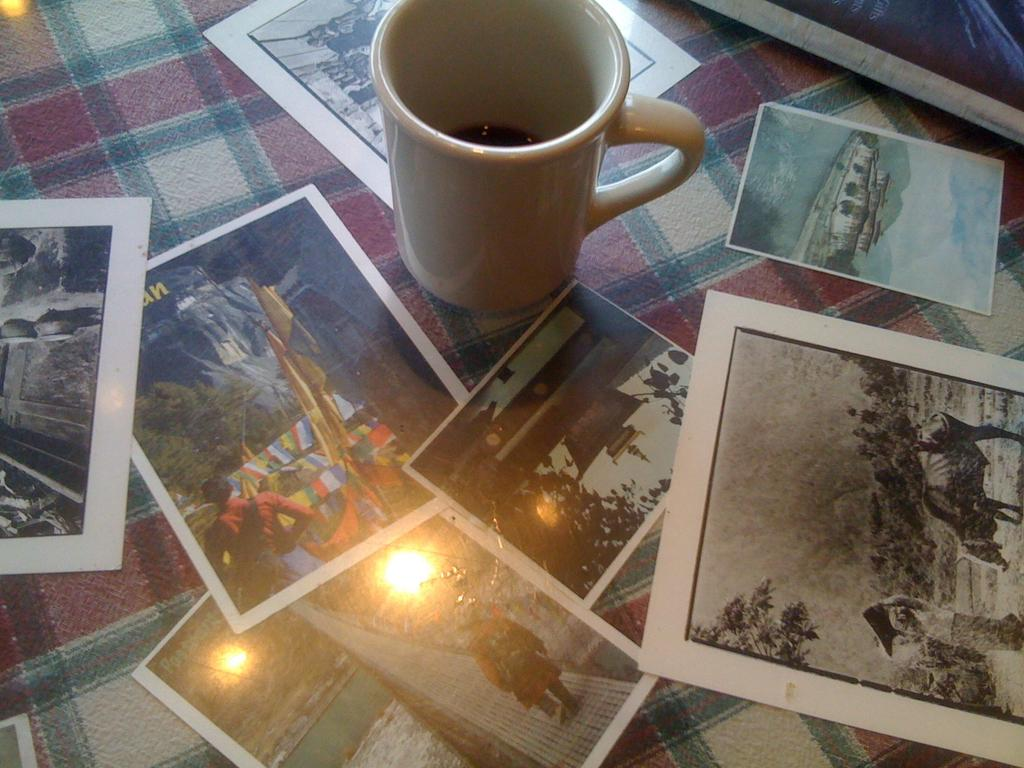What object is present in the image that can hold liquid? There is a cup in the image that can hold liquid. What is inside the cup? There is liquid in the cup. What else can be seen in the image besides the cup and liquid? There are photographs in the image. How are the photographs arranged or displayed? The photographs are placed on a cloth. What day of the week is depicted in the image? There is no indication of a specific day of the week in the image. Is there any evidence of an attack or conflict in the image? No, there is no evidence of an attack or conflict in the image. 